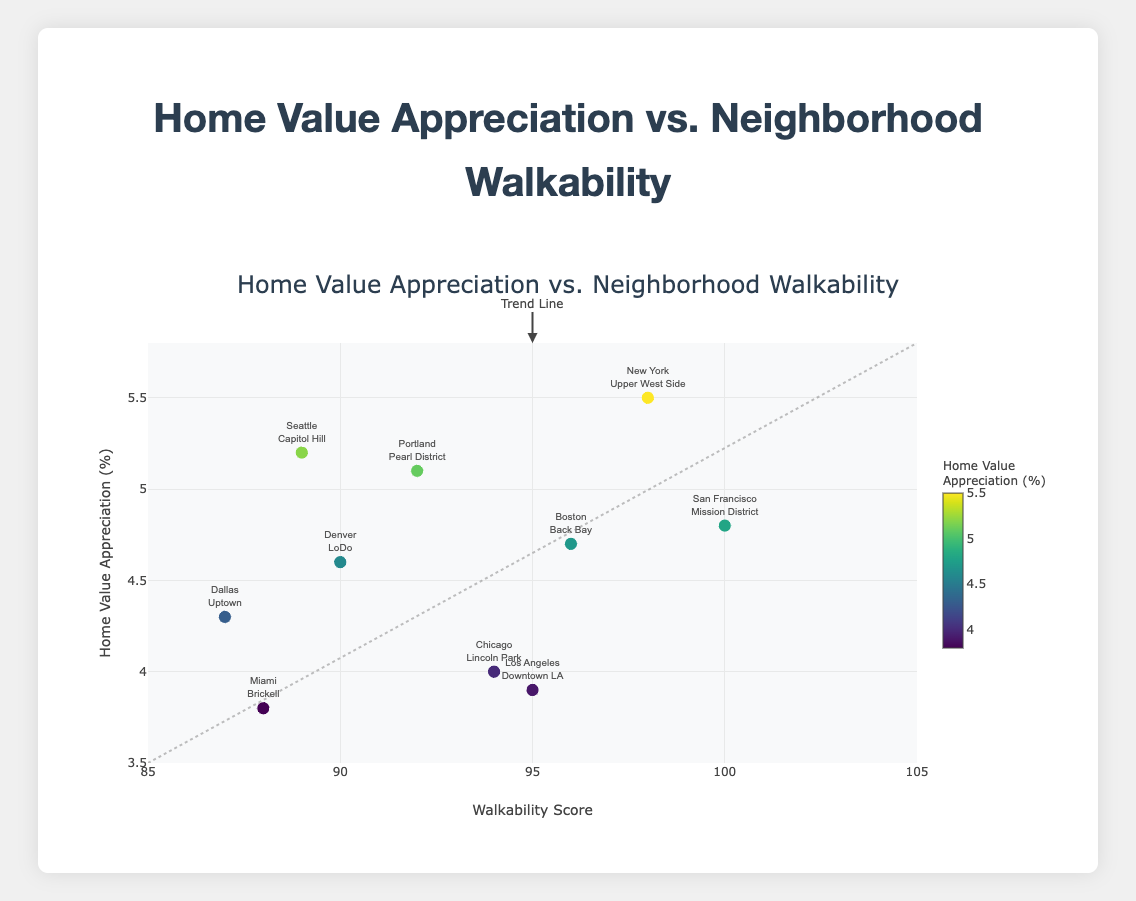What's the title of the figure? The title of the figure is prominently displayed at the top in a larger font size.
Answer: Home Value Appreciation vs. Neighborhood Walkability What is the walkability score range displayed on the x-axis? The x-axis range is indicated by the extremes of the horizontal axis.
Answer: 85 to 105 How many data points are represented in the scatter plot? Each marker on the scatter plot represents one data point, and there is a total of one marker per neighborhood listed in the provided data.
Answer: 10 What city and neighborhood combination has the highest home value appreciation? By observing the y-axis for the highest value and checking the corresponding label, we find the highest home value appreciation.
Answer: New York, Upper West Side Which neighborhood has the maximum walkability score? The maximum walkability score is 100, and the associated neighborhood is indicated in the hovertext or label.
Answer: San Francisco, Mission District What is the approximate average home value appreciation across all neighborhoods? Sum the home value appreciation percentages and divide by the number of data points: (5.2 + 4.8 + 5.5 + 4.7 + 4.0 + 5.1 + 3.9 + 4.3 + 4.6 + 3.8) / 10 = 4.59.
Answer: 4.59 How does the home value appreciation in the Mission District compare to Capitol Hill? Compare the y-axis values for both neighborhoods. Mission District has an appreciation of 4.8% while Capitol Hill is 5.2%.
Answer: Capitol Hill is higher What is the minimum home value appreciation percentage shown? The y-axis displays the home value appreciation, and the minimum value can be found at the lowest point.
Answer: 3.8 Is there a trend line drawn in the scatter plot, and if so, what is it indicating? The trend line is present and annotated; it indicates a general trend of increasing home value appreciation with higher walkability scores.
Answer: Yes, upward trend 